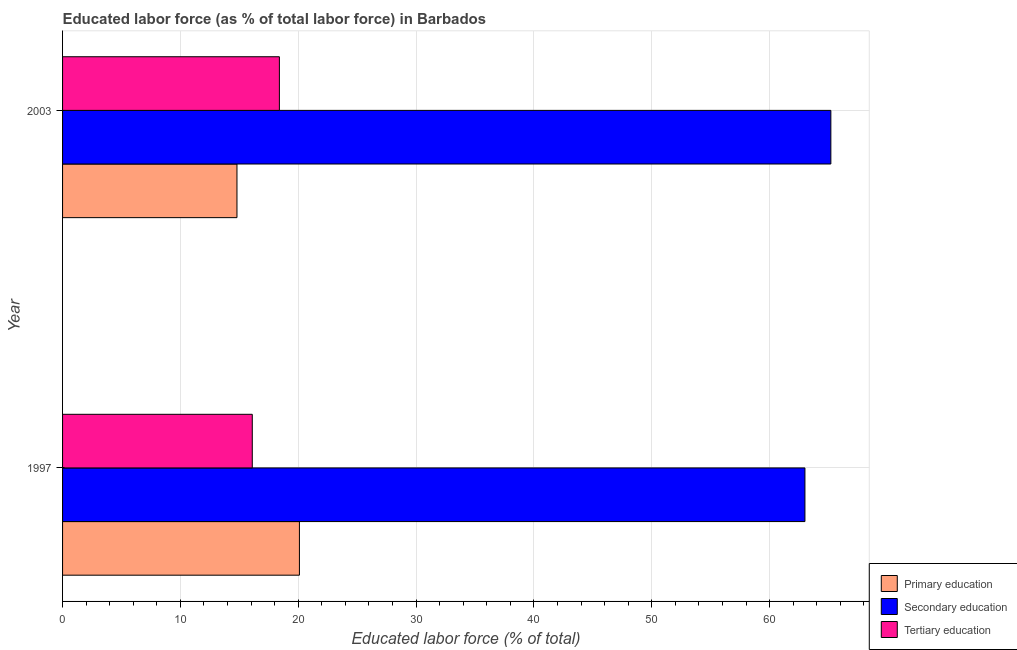How many groups of bars are there?
Offer a very short reply. 2. How many bars are there on the 1st tick from the bottom?
Your answer should be very brief. 3. Across all years, what is the maximum percentage of labor force who received tertiary education?
Keep it short and to the point. 18.4. What is the total percentage of labor force who received tertiary education in the graph?
Offer a terse response. 34.5. What is the difference between the percentage of labor force who received secondary education in 2003 and the percentage of labor force who received primary education in 1997?
Offer a terse response. 45.1. What is the average percentage of labor force who received secondary education per year?
Offer a terse response. 64.1. In the year 2003, what is the difference between the percentage of labor force who received secondary education and percentage of labor force who received primary education?
Give a very brief answer. 50.4. In how many years, is the percentage of labor force who received tertiary education greater than the average percentage of labor force who received tertiary education taken over all years?
Offer a very short reply. 1. What does the 1st bar from the top in 1997 represents?
Provide a succinct answer. Tertiary education. Is it the case that in every year, the sum of the percentage of labor force who received primary education and percentage of labor force who received secondary education is greater than the percentage of labor force who received tertiary education?
Keep it short and to the point. Yes. How many bars are there?
Your answer should be very brief. 6. What is the difference between two consecutive major ticks on the X-axis?
Make the answer very short. 10. Does the graph contain grids?
Give a very brief answer. Yes. Where does the legend appear in the graph?
Your response must be concise. Bottom right. How many legend labels are there?
Ensure brevity in your answer.  3. How are the legend labels stacked?
Keep it short and to the point. Vertical. What is the title of the graph?
Make the answer very short. Educated labor force (as % of total labor force) in Barbados. Does "Taxes on goods and services" appear as one of the legend labels in the graph?
Provide a short and direct response. No. What is the label or title of the X-axis?
Provide a succinct answer. Educated labor force (% of total). What is the Educated labor force (% of total) in Primary education in 1997?
Give a very brief answer. 20.1. What is the Educated labor force (% of total) in Secondary education in 1997?
Your response must be concise. 63. What is the Educated labor force (% of total) in Tertiary education in 1997?
Make the answer very short. 16.1. What is the Educated labor force (% of total) of Primary education in 2003?
Your answer should be very brief. 14.8. What is the Educated labor force (% of total) of Secondary education in 2003?
Make the answer very short. 65.2. What is the Educated labor force (% of total) in Tertiary education in 2003?
Give a very brief answer. 18.4. Across all years, what is the maximum Educated labor force (% of total) of Primary education?
Your response must be concise. 20.1. Across all years, what is the maximum Educated labor force (% of total) in Secondary education?
Offer a very short reply. 65.2. Across all years, what is the maximum Educated labor force (% of total) of Tertiary education?
Ensure brevity in your answer.  18.4. Across all years, what is the minimum Educated labor force (% of total) in Primary education?
Offer a very short reply. 14.8. Across all years, what is the minimum Educated labor force (% of total) of Secondary education?
Give a very brief answer. 63. Across all years, what is the minimum Educated labor force (% of total) in Tertiary education?
Provide a short and direct response. 16.1. What is the total Educated labor force (% of total) in Primary education in the graph?
Ensure brevity in your answer.  34.9. What is the total Educated labor force (% of total) of Secondary education in the graph?
Give a very brief answer. 128.2. What is the total Educated labor force (% of total) of Tertiary education in the graph?
Offer a terse response. 34.5. What is the difference between the Educated labor force (% of total) in Secondary education in 1997 and that in 2003?
Provide a short and direct response. -2.2. What is the difference between the Educated labor force (% of total) of Tertiary education in 1997 and that in 2003?
Offer a terse response. -2.3. What is the difference between the Educated labor force (% of total) in Primary education in 1997 and the Educated labor force (% of total) in Secondary education in 2003?
Offer a terse response. -45.1. What is the difference between the Educated labor force (% of total) of Secondary education in 1997 and the Educated labor force (% of total) of Tertiary education in 2003?
Make the answer very short. 44.6. What is the average Educated labor force (% of total) of Primary education per year?
Provide a short and direct response. 17.45. What is the average Educated labor force (% of total) in Secondary education per year?
Give a very brief answer. 64.1. What is the average Educated labor force (% of total) of Tertiary education per year?
Keep it short and to the point. 17.25. In the year 1997, what is the difference between the Educated labor force (% of total) of Primary education and Educated labor force (% of total) of Secondary education?
Keep it short and to the point. -42.9. In the year 1997, what is the difference between the Educated labor force (% of total) in Secondary education and Educated labor force (% of total) in Tertiary education?
Your answer should be compact. 46.9. In the year 2003, what is the difference between the Educated labor force (% of total) in Primary education and Educated labor force (% of total) in Secondary education?
Your answer should be very brief. -50.4. In the year 2003, what is the difference between the Educated labor force (% of total) in Secondary education and Educated labor force (% of total) in Tertiary education?
Provide a succinct answer. 46.8. What is the ratio of the Educated labor force (% of total) in Primary education in 1997 to that in 2003?
Give a very brief answer. 1.36. What is the ratio of the Educated labor force (% of total) of Secondary education in 1997 to that in 2003?
Make the answer very short. 0.97. What is the difference between the highest and the second highest Educated labor force (% of total) of Secondary education?
Offer a terse response. 2.2. What is the difference between the highest and the lowest Educated labor force (% of total) in Secondary education?
Keep it short and to the point. 2.2. 